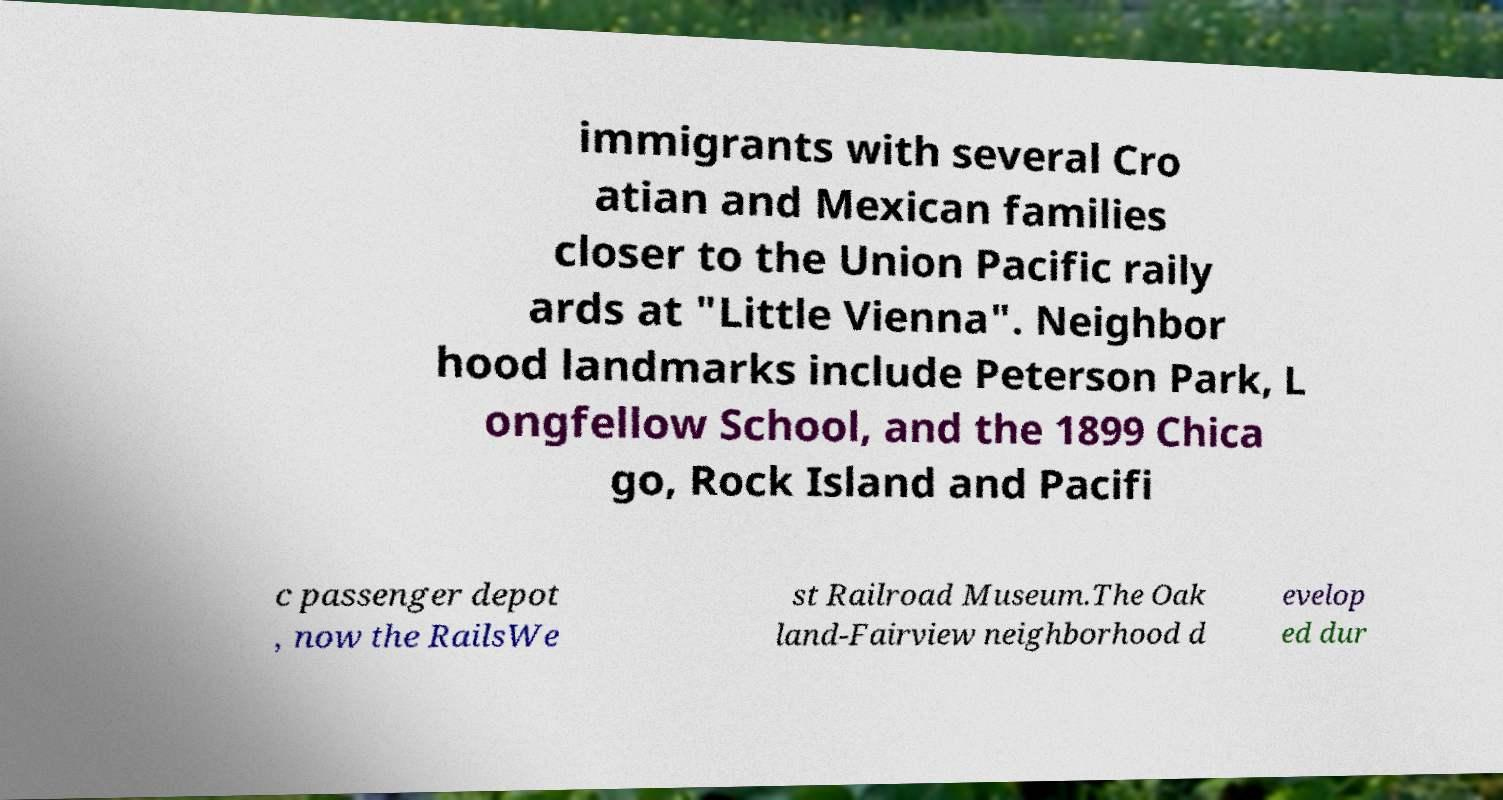For documentation purposes, I need the text within this image transcribed. Could you provide that? immigrants with several Cro atian and Mexican families closer to the Union Pacific raily ards at "Little Vienna". Neighbor hood landmarks include Peterson Park, L ongfellow School, and the 1899 Chica go, Rock Island and Pacifi c passenger depot , now the RailsWe st Railroad Museum.The Oak land-Fairview neighborhood d evelop ed dur 